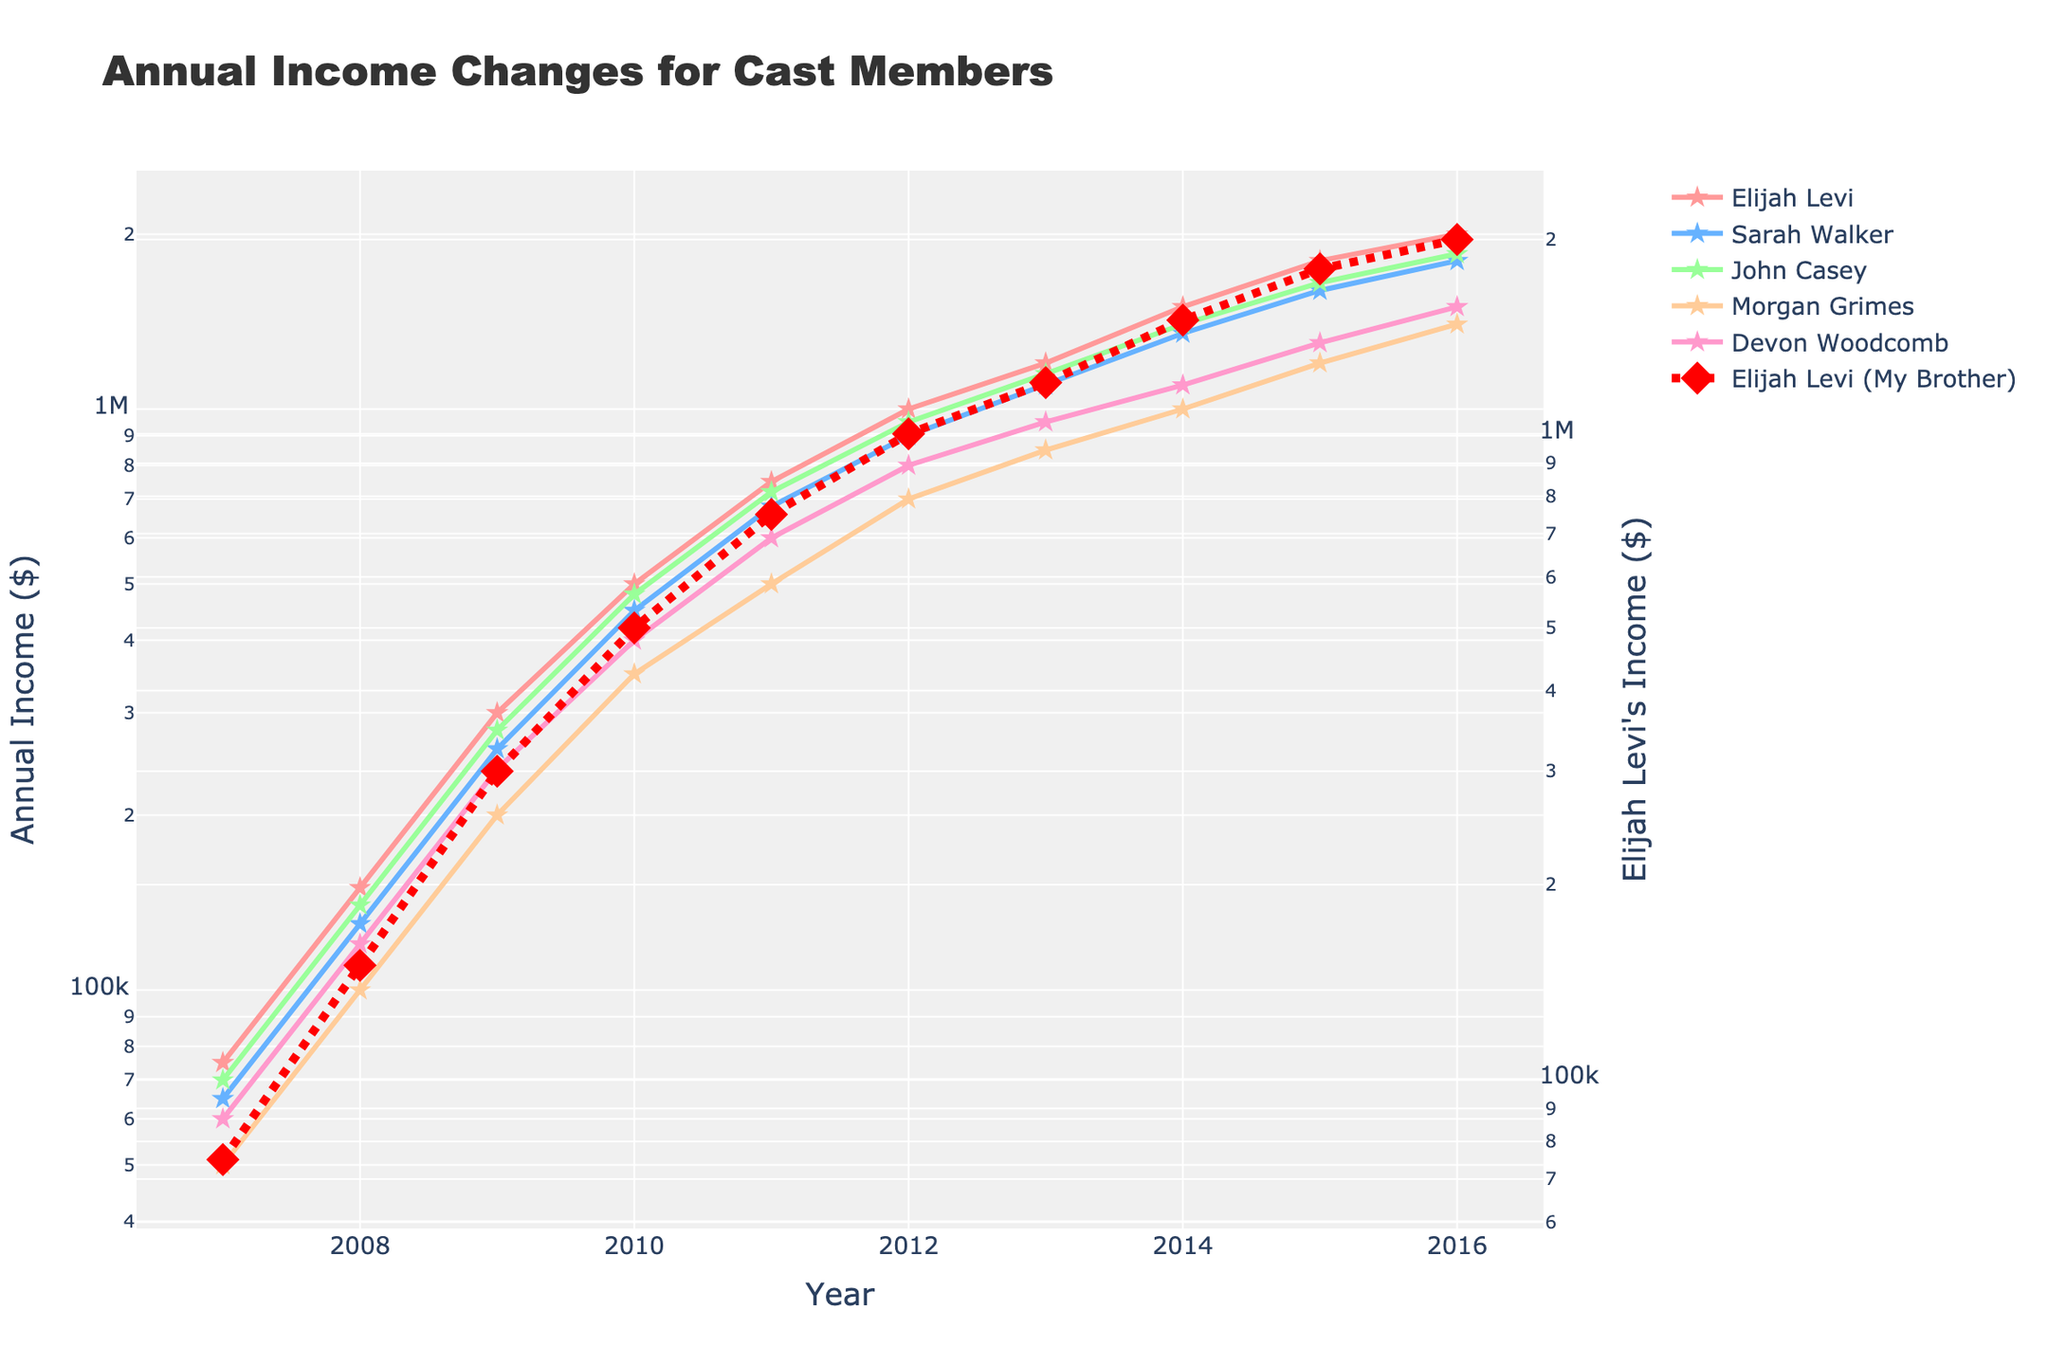What is the annual income for Sarah Walker in 2012? Check the value for Sarah Walker's income in the year 2012 which is marked with a specific color and symbol in the chart.
Answer: 900,000 In which year did Elijah Levi surpass the 1 million income mark? Identify the year when Elijah Levi's income first exceeds 1 million dollars by looking at the trend line specific to Elijah Levi.
Answer: 2012 Whose income increased the most between 2011 and 2012? Calculate the difference in income from 2011 to 2012 for each cast member and compare to determine the largest increase.
Answer: Elijah Levi Which character had the lowest annual income in 2007? Compare the plotted income values for all cast members in the year 2007 to find the minimum value.
Answer: Morgan Grimes What is the average income of Devon Woodcomb over the 10-year period? Sum up Devon Woodcomb's income values from 2007 to 2016 and divide by the number of years (10).
Answer: 810,000 Who had a higher income in 2010: John Casey or Morgan Grimes? Compare the incomes of John Casey and Morgan Grimes in the year 2010 by referring to their respective trend lines.
Answer: John Casey Did any character's income double from 2009 to 2010? Check each cast member's income in 2009 and 2010 to see if any character's income in 2010 is exactly twice that of 2009.
Answer: No Which character’s income shows the most noticeable increase over the years by visually inspecting the steepest line segment or notable upward trends? View the chart to identify the trend line with the steepest slope or the most noticeable upward trend.
Answer: Elijah Levi What was the difference between Devon Woodcomb and Morgan Grimes' incomes in 2016? Subtract Morgan Grimes' income in 2016 from Devon Woodcomb's income in the same year.
Answer: 100,000 How does Elijah Levi's income growth compare with the other cast members overall? Look at Elijah Levi's trend line and compare its steepness and overall increase with those of other characters to understand the relative growth rate.
Answer: Elijah Levi's income growth is significantly higher than other cast members 